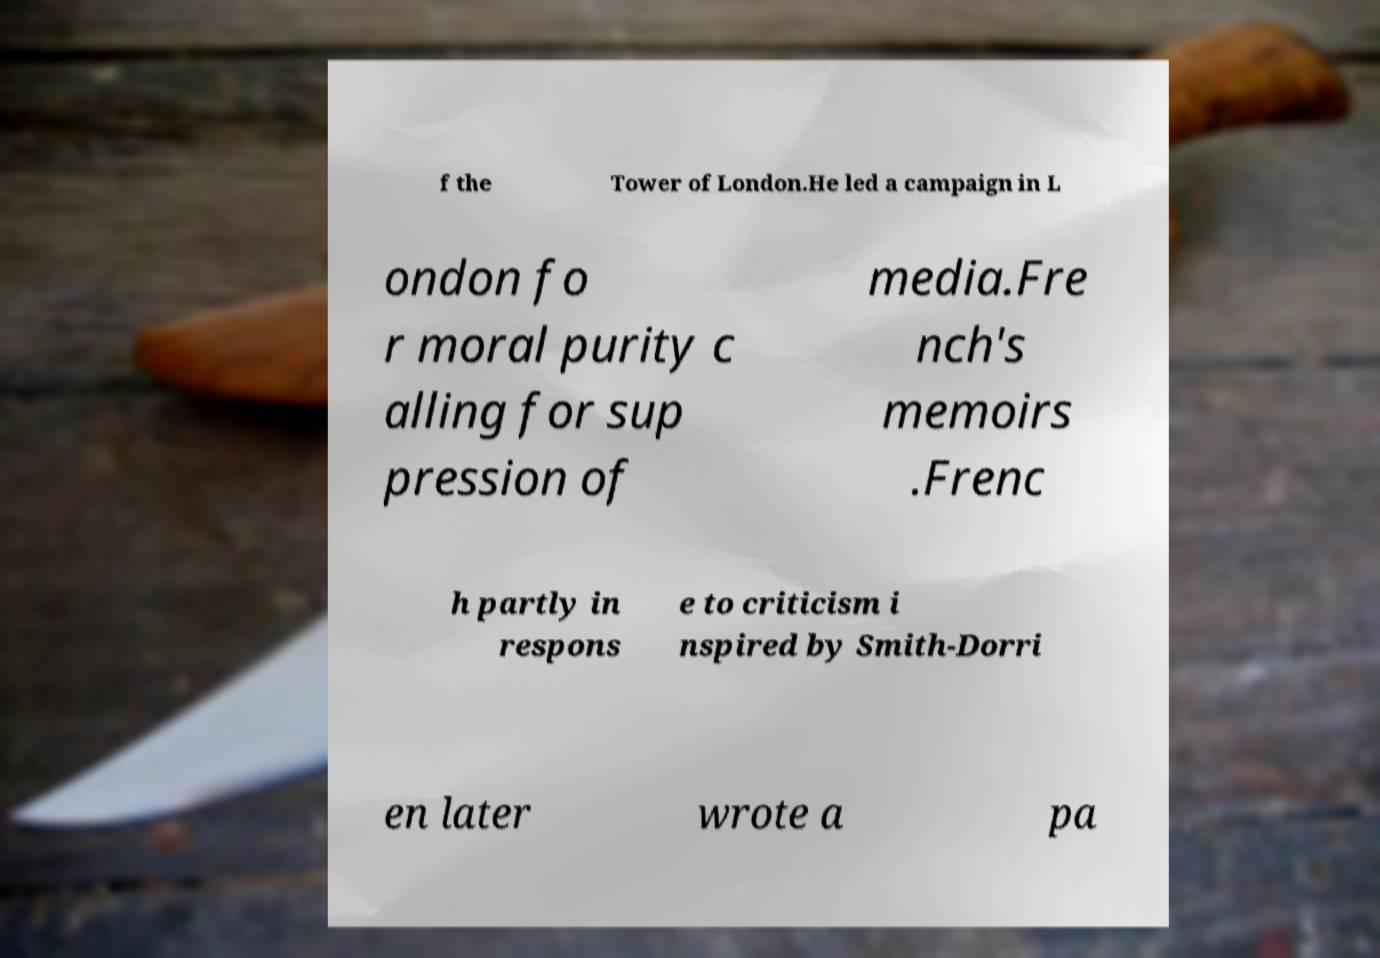Could you assist in decoding the text presented in this image and type it out clearly? f the Tower of London.He led a campaign in L ondon fo r moral purity c alling for sup pression of media.Fre nch's memoirs .Frenc h partly in respons e to criticism i nspired by Smith-Dorri en later wrote a pa 